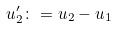Convert formula to latex. <formula><loc_0><loc_0><loc_500><loc_500>u _ { 2 } ^ { \prime } \colon = u _ { 2 } - u _ { 1 }</formula> 